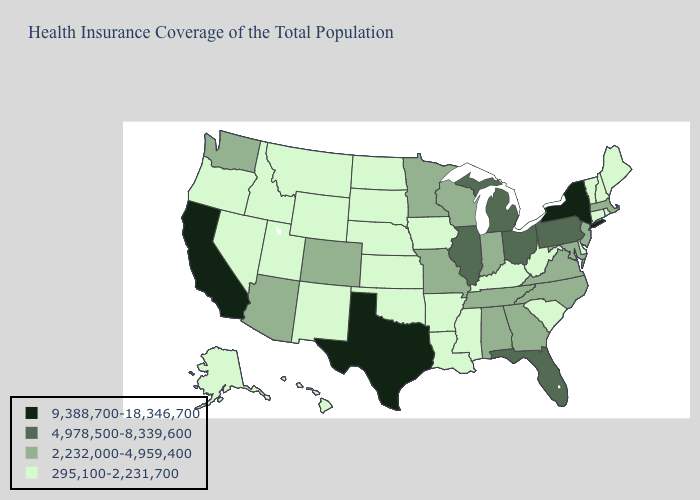Name the states that have a value in the range 4,978,500-8,339,600?
Short answer required. Florida, Illinois, Michigan, Ohio, Pennsylvania. What is the highest value in the USA?
Write a very short answer. 9,388,700-18,346,700. Name the states that have a value in the range 9,388,700-18,346,700?
Concise answer only. California, New York, Texas. Which states have the highest value in the USA?
Answer briefly. California, New York, Texas. Among the states that border Alabama , does Florida have the highest value?
Quick response, please. Yes. Name the states that have a value in the range 9,388,700-18,346,700?
Keep it brief. California, New York, Texas. What is the highest value in states that border Kentucky?
Short answer required. 4,978,500-8,339,600. What is the value of Maine?
Keep it brief. 295,100-2,231,700. What is the value of Connecticut?
Answer briefly. 295,100-2,231,700. Name the states that have a value in the range 4,978,500-8,339,600?
Quick response, please. Florida, Illinois, Michigan, Ohio, Pennsylvania. Which states have the highest value in the USA?
Quick response, please. California, New York, Texas. Does Illinois have a higher value than Pennsylvania?
Give a very brief answer. No. What is the value of South Dakota?
Concise answer only. 295,100-2,231,700. What is the value of North Dakota?
Quick response, please. 295,100-2,231,700. 